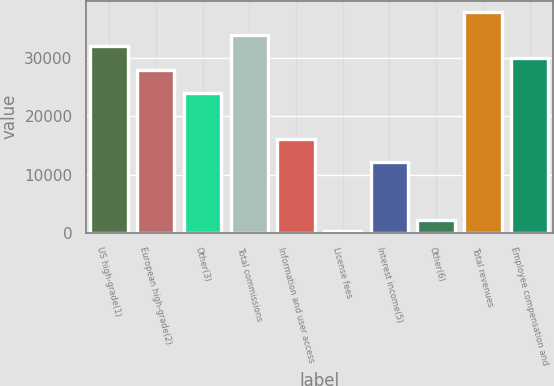Convert chart. <chart><loc_0><loc_0><loc_500><loc_500><bar_chart><fcel>US high-grade(1)<fcel>European high-grade(2)<fcel>Other(3)<fcel>Total commissions<fcel>Information and user access<fcel>License fees<fcel>Interest income(5)<fcel>Other(6)<fcel>Total revenues<fcel>Employee compensation and<nl><fcel>32066.8<fcel>28085.2<fcel>24103.6<fcel>34057.6<fcel>16140.4<fcel>214<fcel>12158.8<fcel>2204.8<fcel>38039.2<fcel>30076<nl></chart> 